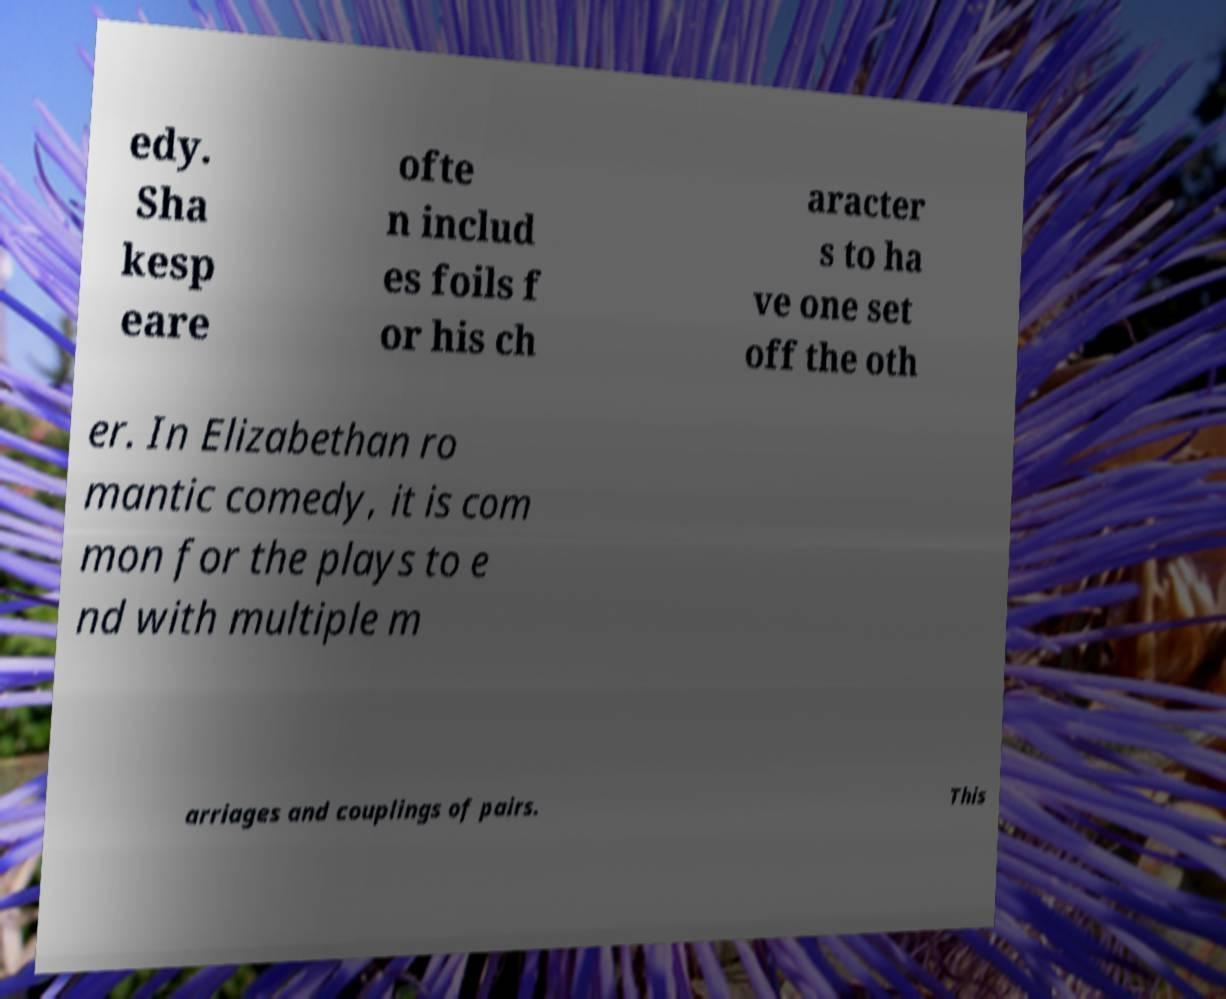I need the written content from this picture converted into text. Can you do that? edy. Sha kesp eare ofte n includ es foils f or his ch aracter s to ha ve one set off the oth er. In Elizabethan ro mantic comedy, it is com mon for the plays to e nd with multiple m arriages and couplings of pairs. This 